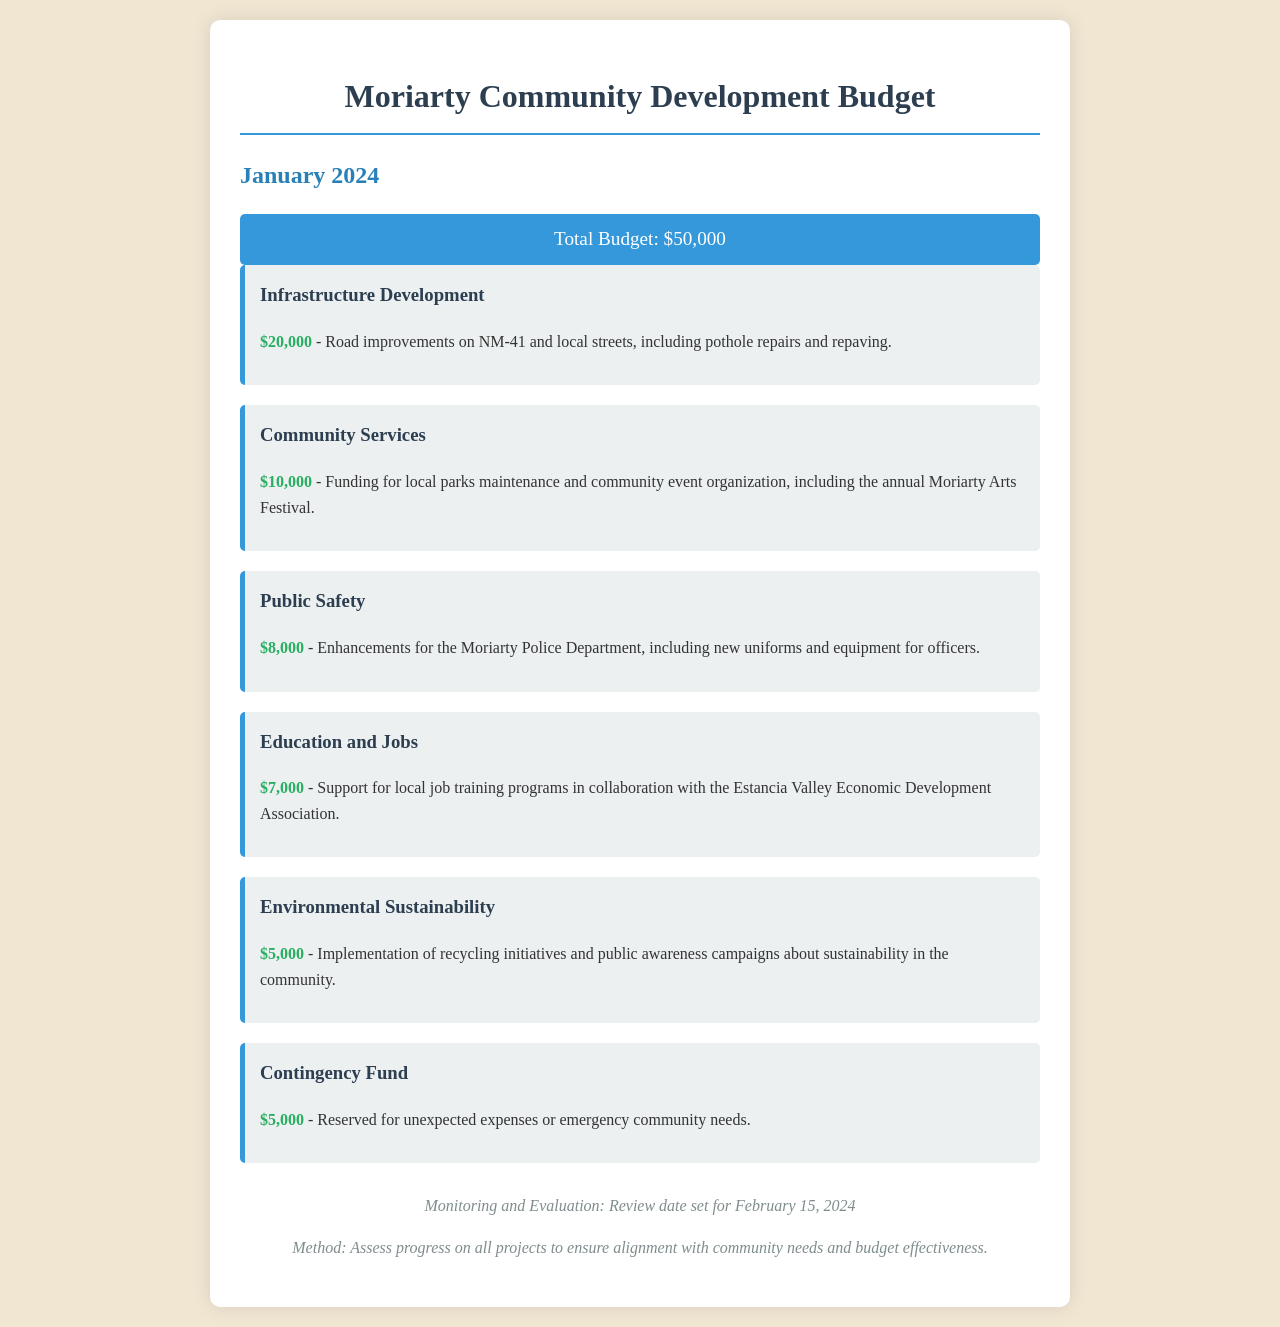What is the total budget allocated for January 2024? The total budget is stated clearly as $50,000 in the document.
Answer: $50,000 How much is allocated for infrastructure development? The budget item for infrastructure development specifies an amount of $20,000.
Answer: $20,000 What project is funded under community services? The community services section mentions maintenance of local parks and the annual Moriarty Arts Festival.
Answer: Moriarty Arts Festival What is the amount set aside for public safety enhancements? The budget indicates that $8,000 is allocated for enhancements for the Moriarty Police Department.
Answer: $8,000 What percentage of the total budget is allocated to education and jobs? The education and jobs allocation of $7,000 is calculated as a percentage of the total budget. (7,000 / 50,000) * 100 = 14%.
Answer: 14% What is the purpose of the contingency fund? The document specifies that the contingency fund is reserved for unexpected expenses or emergency community needs.
Answer: Unexpected expenses When is the review date set for monitoring and evaluation? The review date mentioned in the footer is February 15, 2024.
Answer: February 15, 2024 What funding amount is dedicated to environmental sustainability? The document indicates that $5,000 is allocated for environmental sustainability initiatives.
Answer: $5,000 